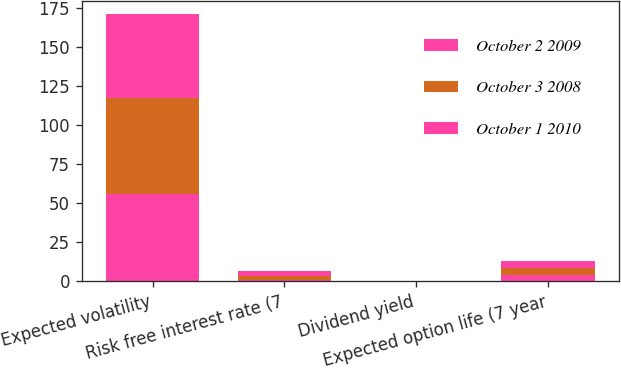<chart> <loc_0><loc_0><loc_500><loc_500><stacked_bar_chart><ecel><fcel>Expected volatility<fcel>Risk free interest rate (7<fcel>Dividend yield<fcel>Expected option life (7 year<nl><fcel>October 2 2009<fcel>56.19<fcel>1.12<fcel>0<fcel>4.23<nl><fcel>October 3 2008<fcel>60.9<fcel>2.36<fcel>0<fcel>4.42<nl><fcel>October 1 2010<fcel>53.87<fcel>3.08<fcel>0<fcel>4.42<nl></chart> 